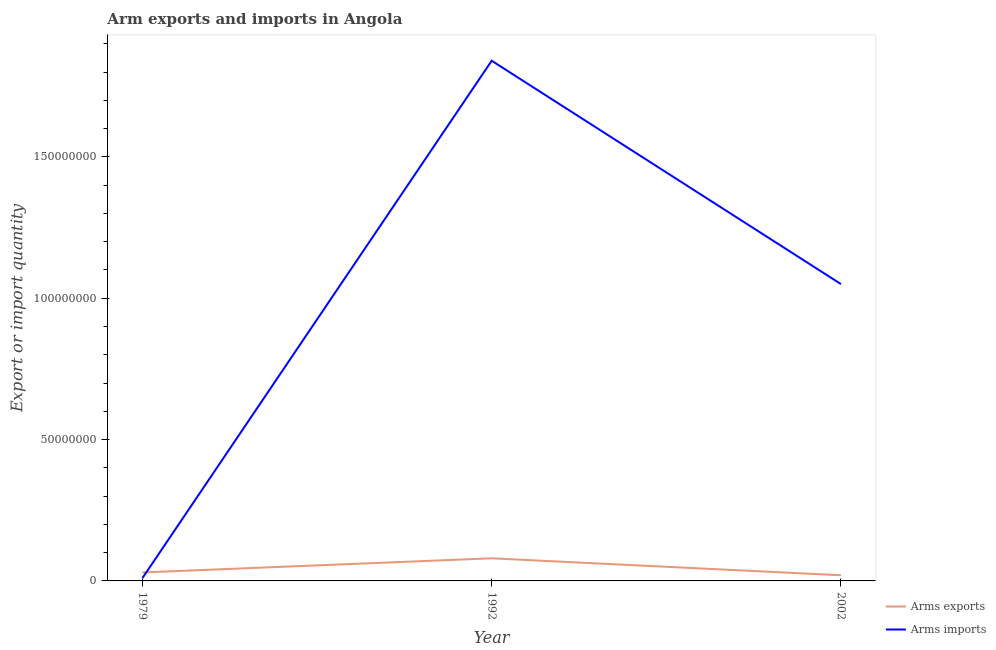How many different coloured lines are there?
Provide a succinct answer. 2. Does the line corresponding to arms exports intersect with the line corresponding to arms imports?
Ensure brevity in your answer.  Yes. What is the arms imports in 2002?
Provide a succinct answer. 1.05e+08. Across all years, what is the maximum arms imports?
Offer a terse response. 1.84e+08. Across all years, what is the minimum arms imports?
Provide a short and direct response. 1.00e+06. In which year was the arms exports maximum?
Give a very brief answer. 1992. In which year was the arms imports minimum?
Provide a short and direct response. 1979. What is the total arms exports in the graph?
Give a very brief answer. 1.30e+07. What is the difference between the arms imports in 1992 and that in 2002?
Your answer should be very brief. 7.90e+07. What is the difference between the arms exports in 2002 and the arms imports in 1992?
Provide a succinct answer. -1.82e+08. What is the average arms imports per year?
Your answer should be very brief. 9.67e+07. In the year 2002, what is the difference between the arms exports and arms imports?
Provide a succinct answer. -1.03e+08. What is the ratio of the arms imports in 1992 to that in 2002?
Keep it short and to the point. 1.75. Is the arms exports in 1979 less than that in 1992?
Offer a very short reply. Yes. Is the difference between the arms imports in 1979 and 2002 greater than the difference between the arms exports in 1979 and 2002?
Provide a succinct answer. No. What is the difference between the highest and the second highest arms exports?
Your answer should be very brief. 5.00e+06. What is the difference between the highest and the lowest arms imports?
Offer a terse response. 1.83e+08. Is the sum of the arms imports in 1979 and 2002 greater than the maximum arms exports across all years?
Give a very brief answer. Yes. How many years are there in the graph?
Give a very brief answer. 3. Does the graph contain any zero values?
Your response must be concise. No. What is the title of the graph?
Your answer should be very brief. Arm exports and imports in Angola. What is the label or title of the X-axis?
Offer a terse response. Year. What is the label or title of the Y-axis?
Your response must be concise. Export or import quantity. What is the Export or import quantity in Arms exports in 1979?
Your response must be concise. 3.00e+06. What is the Export or import quantity of Arms imports in 1979?
Make the answer very short. 1.00e+06. What is the Export or import quantity in Arms imports in 1992?
Your response must be concise. 1.84e+08. What is the Export or import quantity of Arms exports in 2002?
Keep it short and to the point. 2.00e+06. What is the Export or import quantity of Arms imports in 2002?
Offer a terse response. 1.05e+08. Across all years, what is the maximum Export or import quantity in Arms imports?
Make the answer very short. 1.84e+08. What is the total Export or import quantity in Arms exports in the graph?
Provide a short and direct response. 1.30e+07. What is the total Export or import quantity in Arms imports in the graph?
Offer a terse response. 2.90e+08. What is the difference between the Export or import quantity in Arms exports in 1979 and that in 1992?
Your answer should be very brief. -5.00e+06. What is the difference between the Export or import quantity of Arms imports in 1979 and that in 1992?
Give a very brief answer. -1.83e+08. What is the difference between the Export or import quantity in Arms exports in 1979 and that in 2002?
Your answer should be very brief. 1.00e+06. What is the difference between the Export or import quantity of Arms imports in 1979 and that in 2002?
Give a very brief answer. -1.04e+08. What is the difference between the Export or import quantity of Arms exports in 1992 and that in 2002?
Make the answer very short. 6.00e+06. What is the difference between the Export or import quantity in Arms imports in 1992 and that in 2002?
Ensure brevity in your answer.  7.90e+07. What is the difference between the Export or import quantity in Arms exports in 1979 and the Export or import quantity in Arms imports in 1992?
Your answer should be compact. -1.81e+08. What is the difference between the Export or import quantity of Arms exports in 1979 and the Export or import quantity of Arms imports in 2002?
Offer a very short reply. -1.02e+08. What is the difference between the Export or import quantity of Arms exports in 1992 and the Export or import quantity of Arms imports in 2002?
Your answer should be compact. -9.70e+07. What is the average Export or import quantity of Arms exports per year?
Provide a succinct answer. 4.33e+06. What is the average Export or import quantity of Arms imports per year?
Keep it short and to the point. 9.67e+07. In the year 1992, what is the difference between the Export or import quantity of Arms exports and Export or import quantity of Arms imports?
Keep it short and to the point. -1.76e+08. In the year 2002, what is the difference between the Export or import quantity in Arms exports and Export or import quantity in Arms imports?
Make the answer very short. -1.03e+08. What is the ratio of the Export or import quantity in Arms exports in 1979 to that in 1992?
Make the answer very short. 0.38. What is the ratio of the Export or import quantity in Arms imports in 1979 to that in 1992?
Give a very brief answer. 0.01. What is the ratio of the Export or import quantity in Arms exports in 1979 to that in 2002?
Provide a short and direct response. 1.5. What is the ratio of the Export or import quantity of Arms imports in 1979 to that in 2002?
Ensure brevity in your answer.  0.01. What is the ratio of the Export or import quantity in Arms imports in 1992 to that in 2002?
Make the answer very short. 1.75. What is the difference between the highest and the second highest Export or import quantity in Arms imports?
Provide a succinct answer. 7.90e+07. What is the difference between the highest and the lowest Export or import quantity of Arms exports?
Your answer should be compact. 6.00e+06. What is the difference between the highest and the lowest Export or import quantity in Arms imports?
Your answer should be compact. 1.83e+08. 